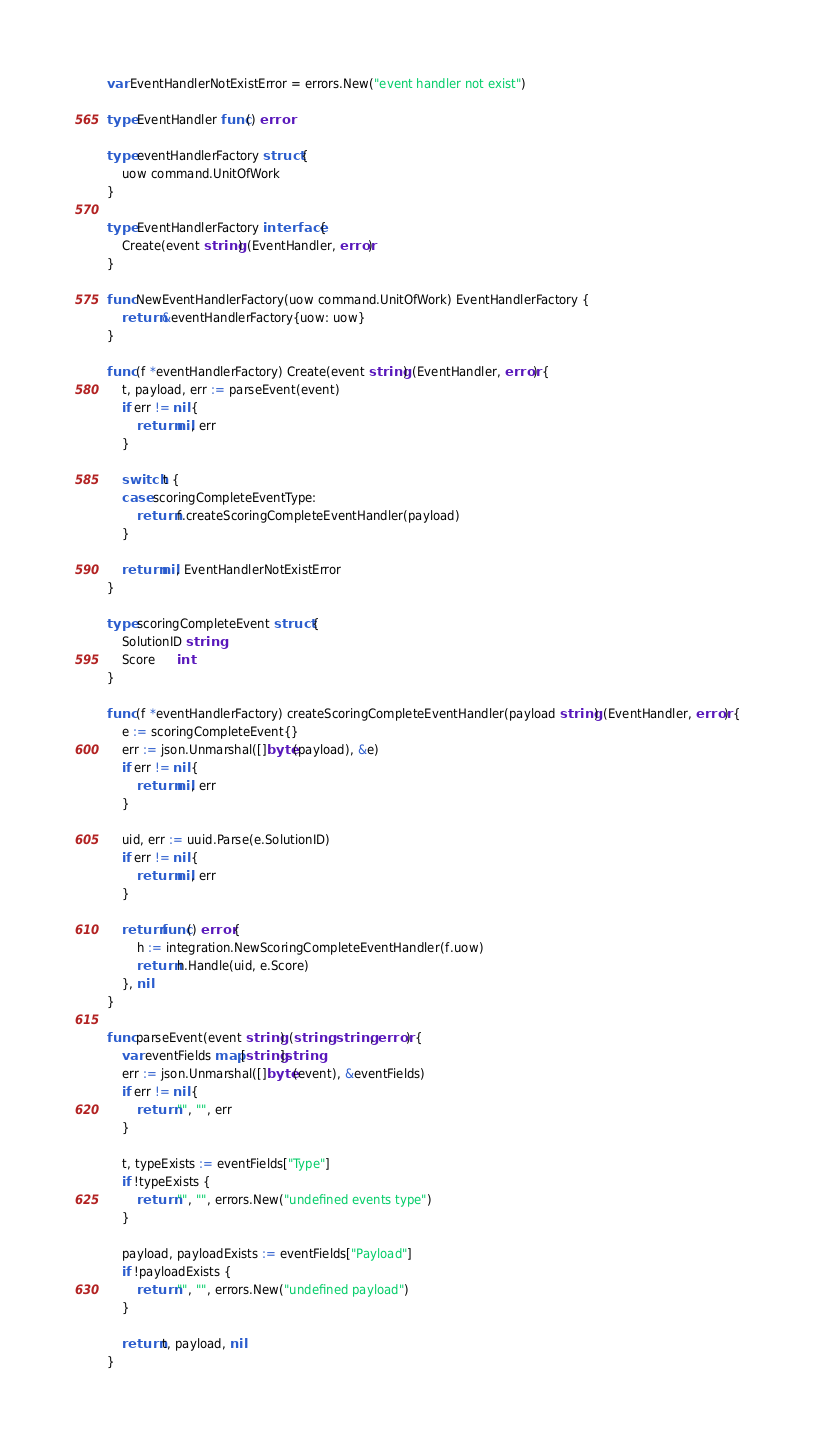Convert code to text. <code><loc_0><loc_0><loc_500><loc_500><_Go_>var EventHandlerNotExistError = errors.New("event handler not exist")

type EventHandler func() error

type eventHandlerFactory struct {
	uow command.UnitOfWork
}

type EventHandlerFactory interface {
	Create(event string) (EventHandler, error)
}

func NewEventHandlerFactory(uow command.UnitOfWork) EventHandlerFactory {
	return &eventHandlerFactory{uow: uow}
}

func (f *eventHandlerFactory) Create(event string) (EventHandler, error) {
	t, payload, err := parseEvent(event)
	if err != nil {
		return nil, err
	}

	switch t {
	case scoringCompleteEventType:
		return f.createScoringCompleteEventHandler(payload)
	}

	return nil, EventHandlerNotExistError
}

type scoringCompleteEvent struct {
	SolutionID string
	Score      int
}

func (f *eventHandlerFactory) createScoringCompleteEventHandler(payload string) (EventHandler, error) {
	e := scoringCompleteEvent{}
	err := json.Unmarshal([]byte(payload), &e)
	if err != nil {
		return nil, err
	}

	uid, err := uuid.Parse(e.SolutionID)
	if err != nil {
		return nil, err
	}

	return func() error {
		h := integration.NewScoringCompleteEventHandler(f.uow)
		return h.Handle(uid, e.Score)
	}, nil
}

func parseEvent(event string) (string, string, error) {
	var eventFields map[string]string
	err := json.Unmarshal([]byte(event), &eventFields)
	if err != nil {
		return "", "", err
	}

	t, typeExists := eventFields["Type"]
	if !typeExists {
		return "", "", errors.New("undefined events type")
	}

	payload, payloadExists := eventFields["Payload"]
	if !payloadExists {
		return "", "", errors.New("undefined payload")
	}

	return t, payload, nil
}
</code> 